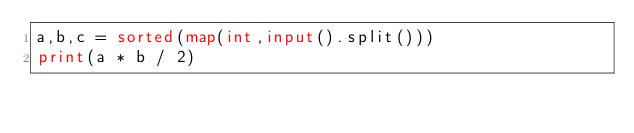Convert code to text. <code><loc_0><loc_0><loc_500><loc_500><_Python_>a,b,c = sorted(map(int,input().split()))
print(a * b / 2) </code> 